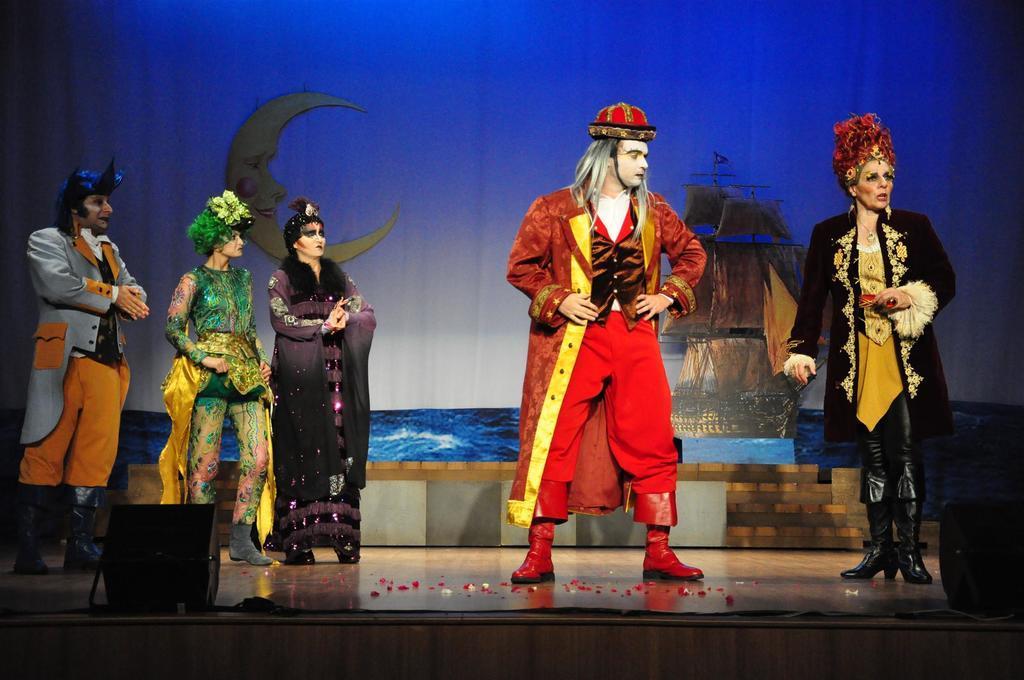Can you describe this image briefly? In this image we can see a group of people wearing the costumes standing on the stage. We can also see the speaker boxes. On the backside we can see a curtain containing some pictures and the structure of a moon on it. 